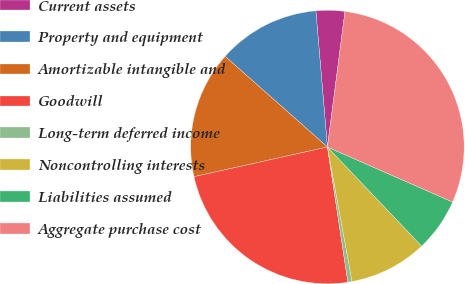<chart> <loc_0><loc_0><loc_500><loc_500><pie_chart><fcel>Current assets<fcel>Property and equipment<fcel>Amortizable intangible and<fcel>Goodwill<fcel>Long-term deferred income<fcel>Noncontrolling interests<fcel>Liabilities assumed<fcel>Aggregate purchase cost<nl><fcel>3.4%<fcel>12.11%<fcel>15.02%<fcel>23.91%<fcel>0.5%<fcel>9.21%<fcel>6.31%<fcel>29.54%<nl></chart> 